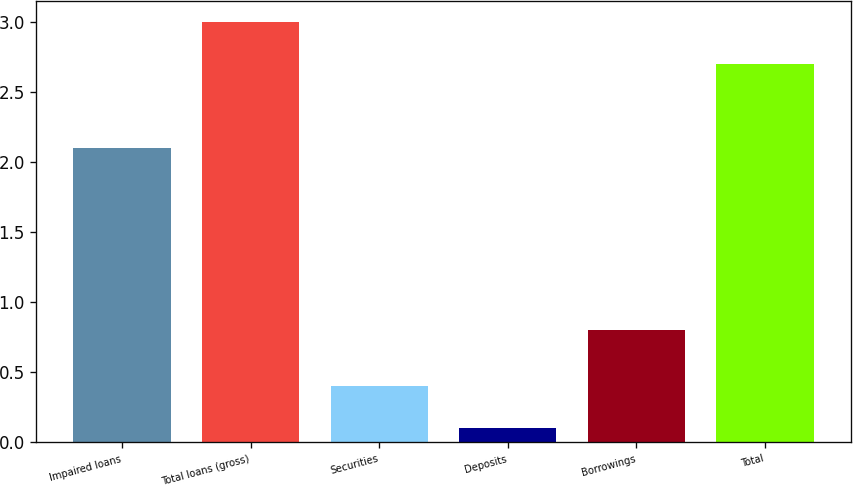Convert chart. <chart><loc_0><loc_0><loc_500><loc_500><bar_chart><fcel>Impaired loans<fcel>Total loans (gross)<fcel>Securities<fcel>Deposits<fcel>Borrowings<fcel>Total<nl><fcel>2.1<fcel>3<fcel>0.4<fcel>0.1<fcel>0.8<fcel>2.7<nl></chart> 